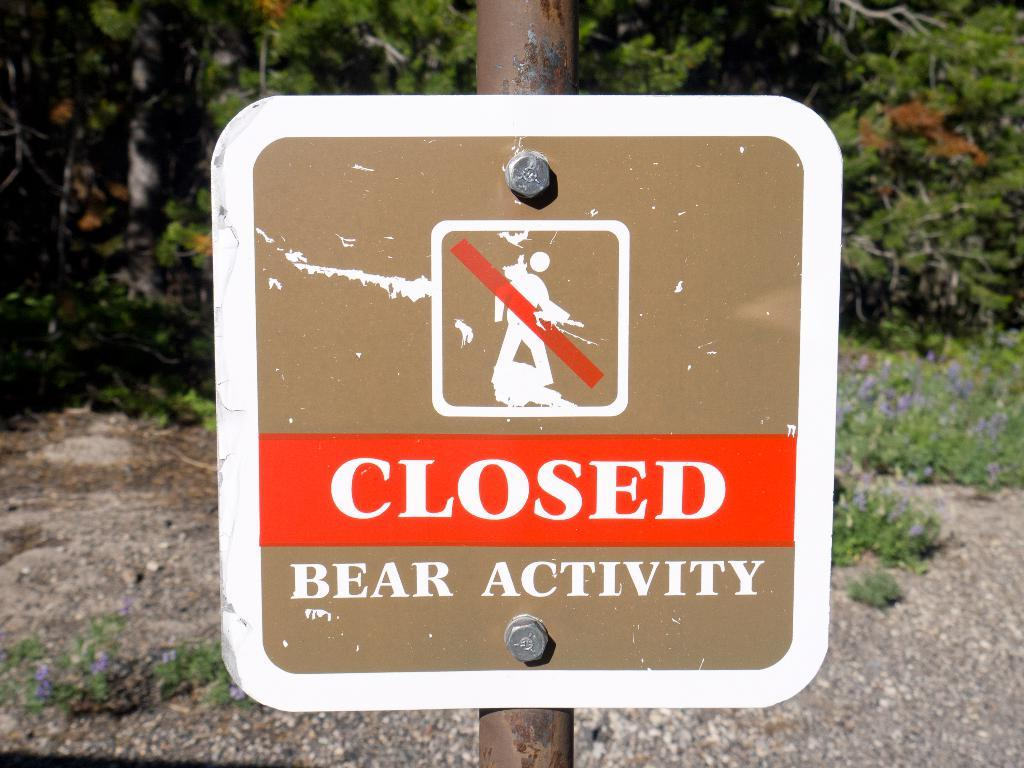What is the main object in the image? There is a board in the image. How is the board connected to the pole? The board is fixed to a pole using bolts. What is the surface beneath the board and pole? There is a ground in the image. What can be seen in the distance in the image? There are trees in the background of the image. How many passengers are sitting on the cake in the image? There is no cake or passengers present in the image. What type of pig can be seen interacting with the board in the image? There is no pig present in the image; only the board, pole, and trees are visible. 